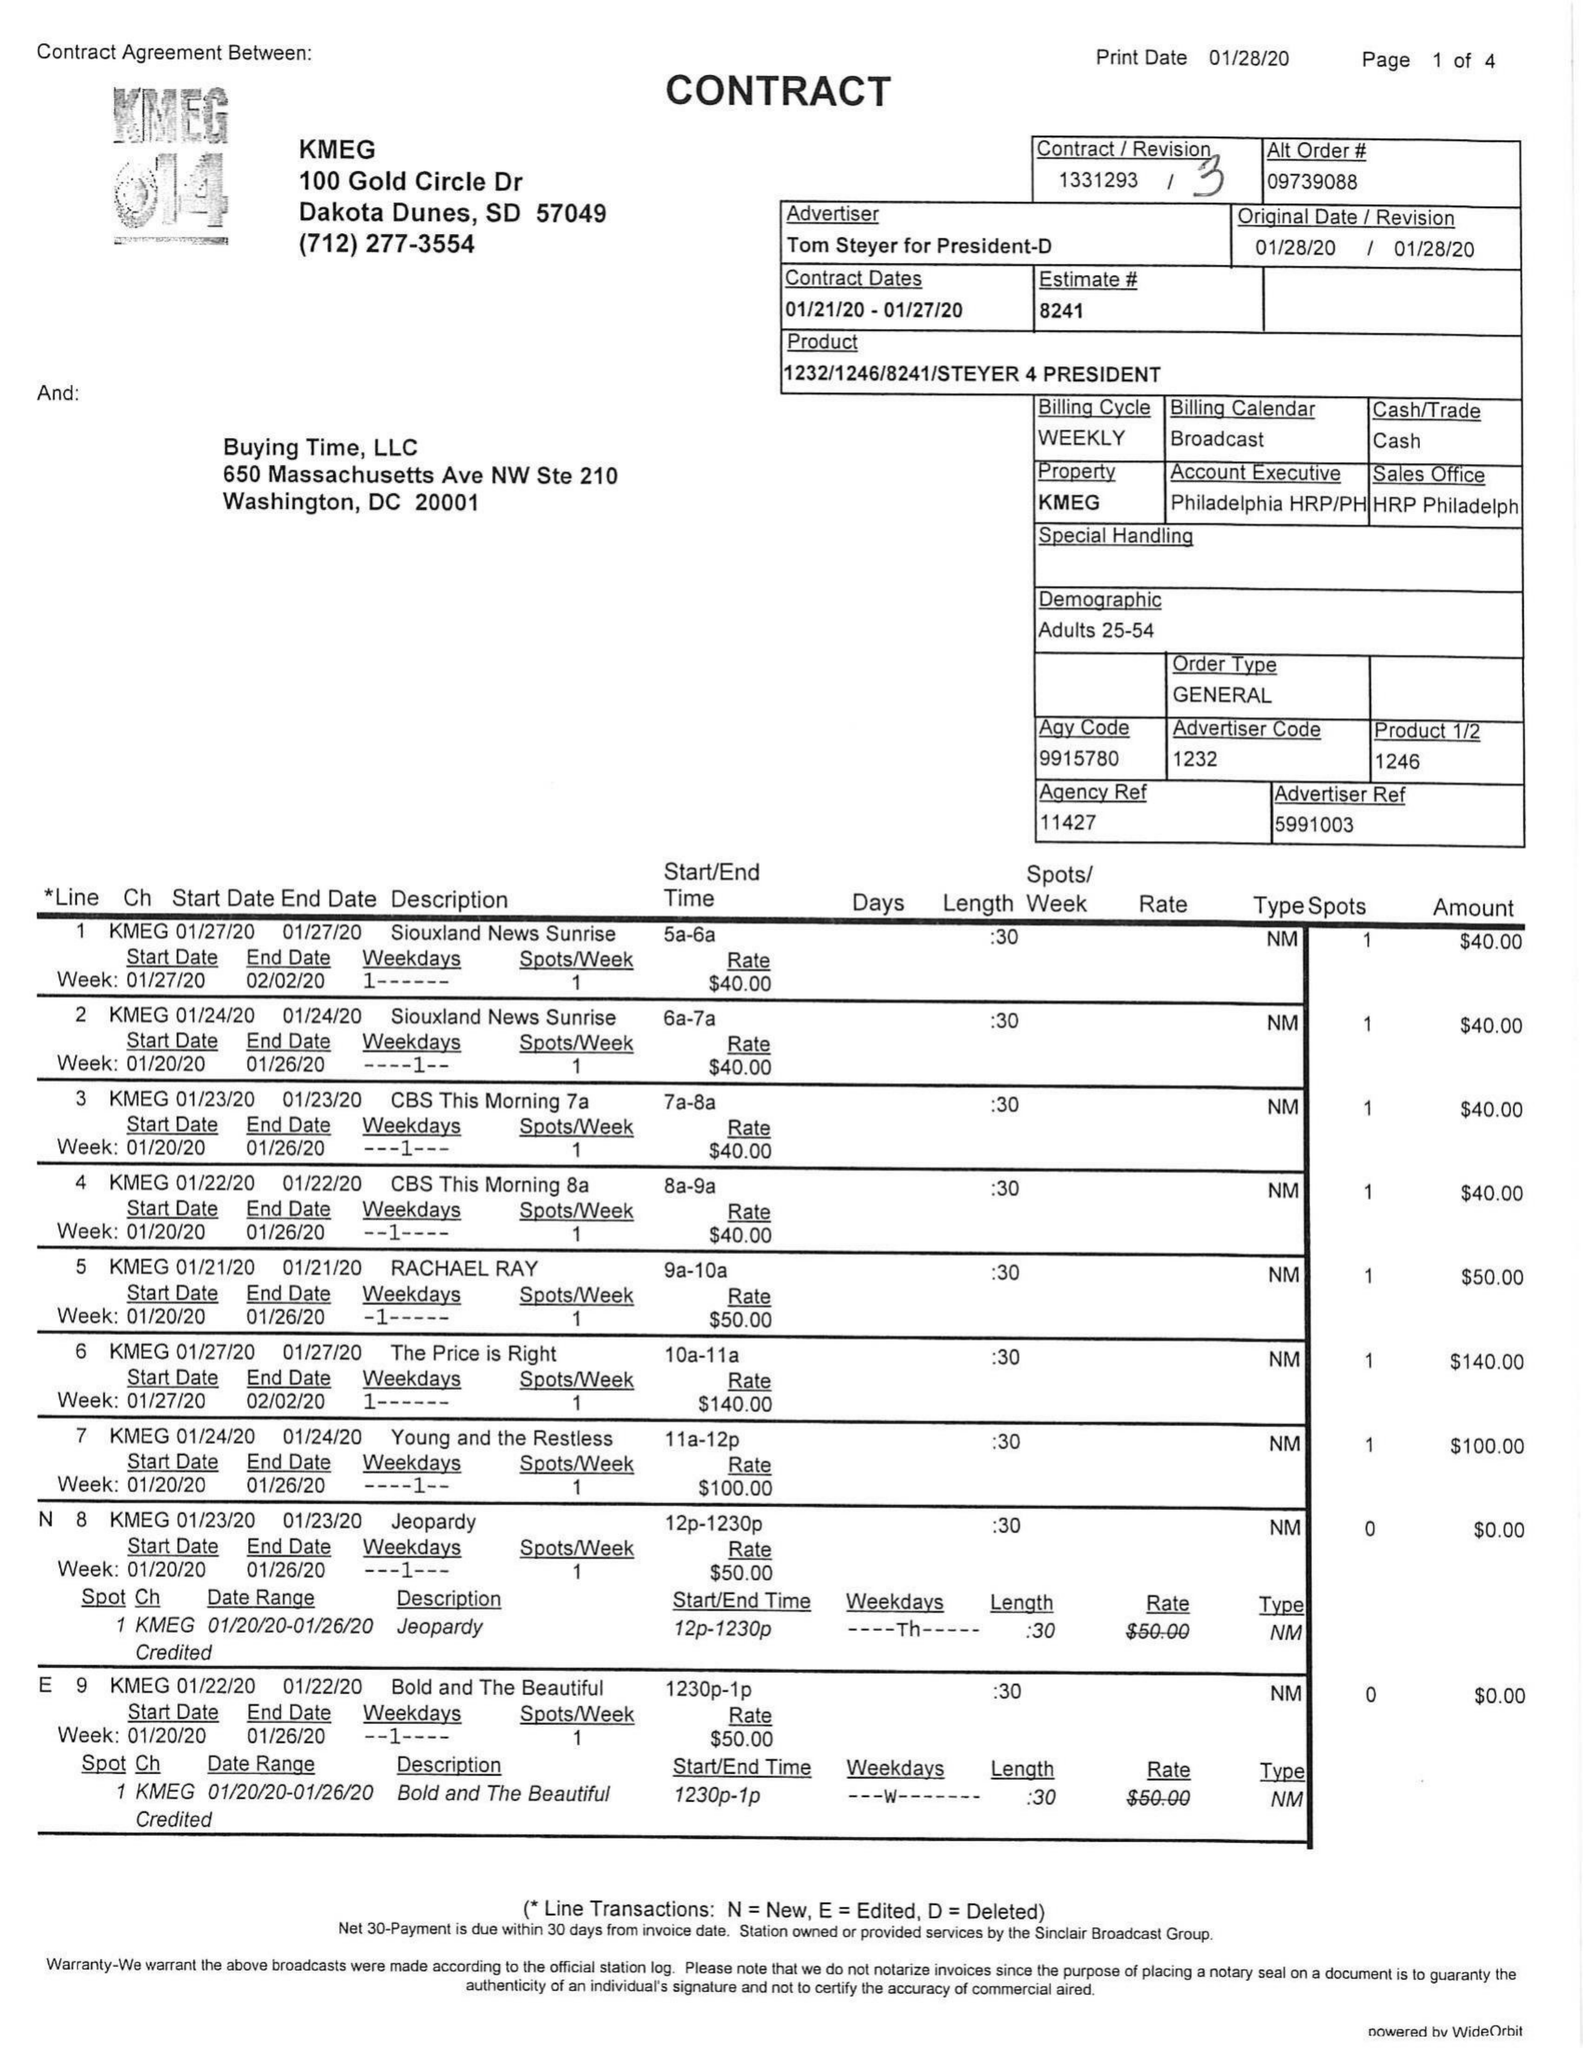What is the value for the advertiser?
Answer the question using a single word or phrase. TOM STEYER FOR PRESIDENT-D 